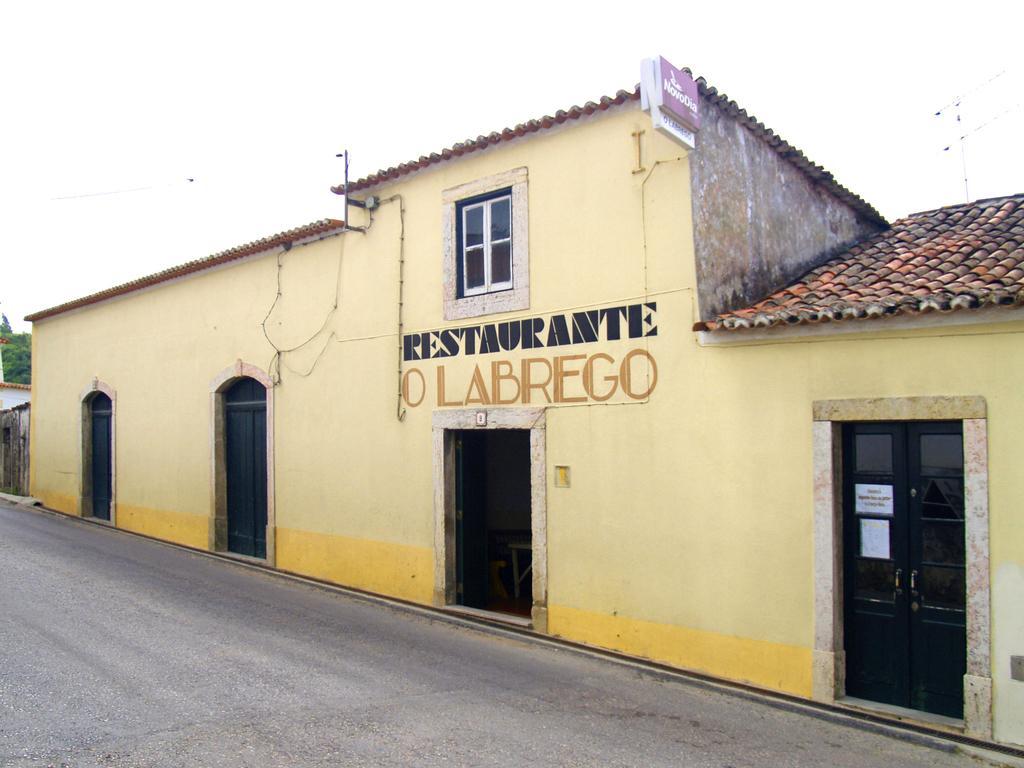In one or two sentences, can you explain what this image depicts? In this image I see a building and I see the doors over here and I see something is written over here and I see the windows and I see the boards over here. In the background I see the sky and I see the greenery over here and I see the road. 